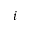Convert formula to latex. <formula><loc_0><loc_0><loc_500><loc_500>i</formula> 